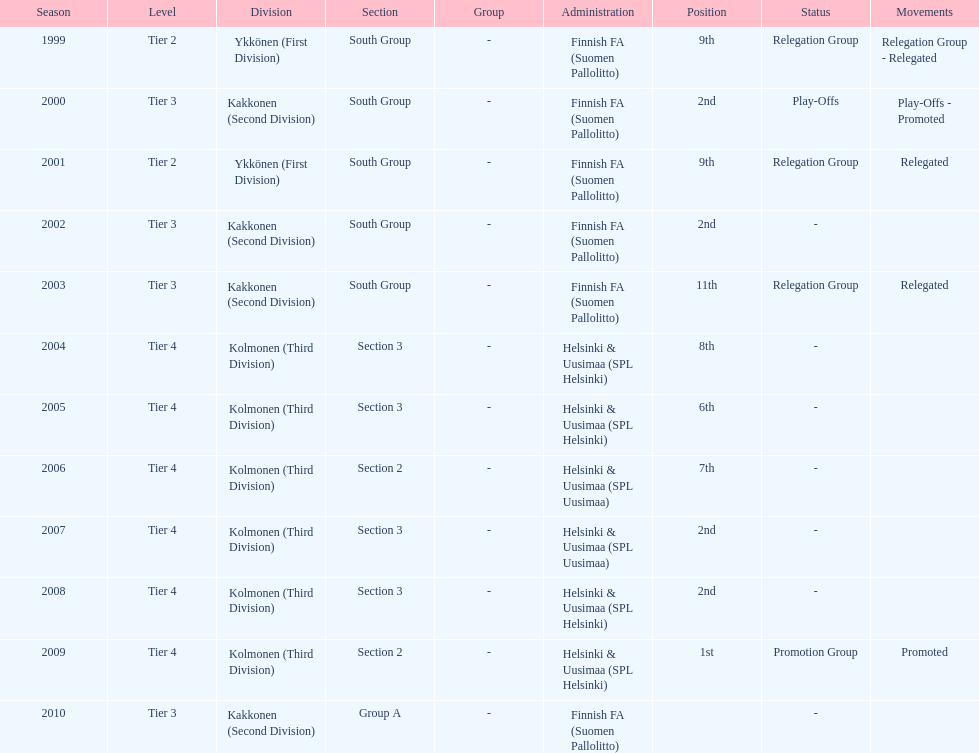Which was the only kolmonen whose movements were promoted? 2009. Could you parse the entire table as a dict? {'header': ['Season', 'Level', 'Division', 'Section', 'Group', 'Administration', 'Position', 'Status', 'Movements'], 'rows': [['1999', 'Tier 2', 'Ykkönen (First Division)', 'South Group', '-', 'Finnish FA (Suomen Pallolitto)', '9th', 'Relegation Group', 'Relegation Group - Relegated'], ['2000', 'Tier 3', 'Kakkonen (Second Division)', 'South Group', '-', 'Finnish FA (Suomen Pallolitto)', '2nd', 'Play-Offs', 'Play-Offs - Promoted'], ['2001', 'Tier 2', 'Ykkönen (First Division)', 'South Group', '-', 'Finnish FA (Suomen Pallolitto)', '9th', 'Relegation Group', 'Relegated'], ['2002', 'Tier 3', 'Kakkonen (Second Division)', 'South Group', '-', 'Finnish FA (Suomen Pallolitto)', '2nd', '-', ''], ['2003', 'Tier 3', 'Kakkonen (Second Division)', 'South Group', '-', 'Finnish FA (Suomen Pallolitto)', '11th', 'Relegation Group', 'Relegated'], ['2004', 'Tier 4', 'Kolmonen (Third Division)', 'Section 3', '-', 'Helsinki & Uusimaa (SPL Helsinki)', '8th', '-', ''], ['2005', 'Tier 4', 'Kolmonen (Third Division)', 'Section 3', '-', 'Helsinki & Uusimaa (SPL Helsinki)', '6th', '-', ''], ['2006', 'Tier 4', 'Kolmonen (Third Division)', 'Section 2', '-', 'Helsinki & Uusimaa (SPL Uusimaa)', '7th', '-', ''], ['2007', 'Tier 4', 'Kolmonen (Third Division)', 'Section 3', '-', 'Helsinki & Uusimaa (SPL Uusimaa)', '2nd', '-', ''], ['2008', 'Tier 4', 'Kolmonen (Third Division)', 'Section 3', '-', 'Helsinki & Uusimaa (SPL Helsinki)', '2nd', '-', ''], ['2009', 'Tier 4', 'Kolmonen (Third Division)', 'Section 2', '-', 'Helsinki & Uusimaa (SPL Helsinki)', '1st', 'Promotion Group', 'Promoted'], ['2010', 'Tier 3', 'Kakkonen (Second Division)', 'Group A', '-', 'Finnish FA (Suomen Pallolitto)', '', '-', '']]} 